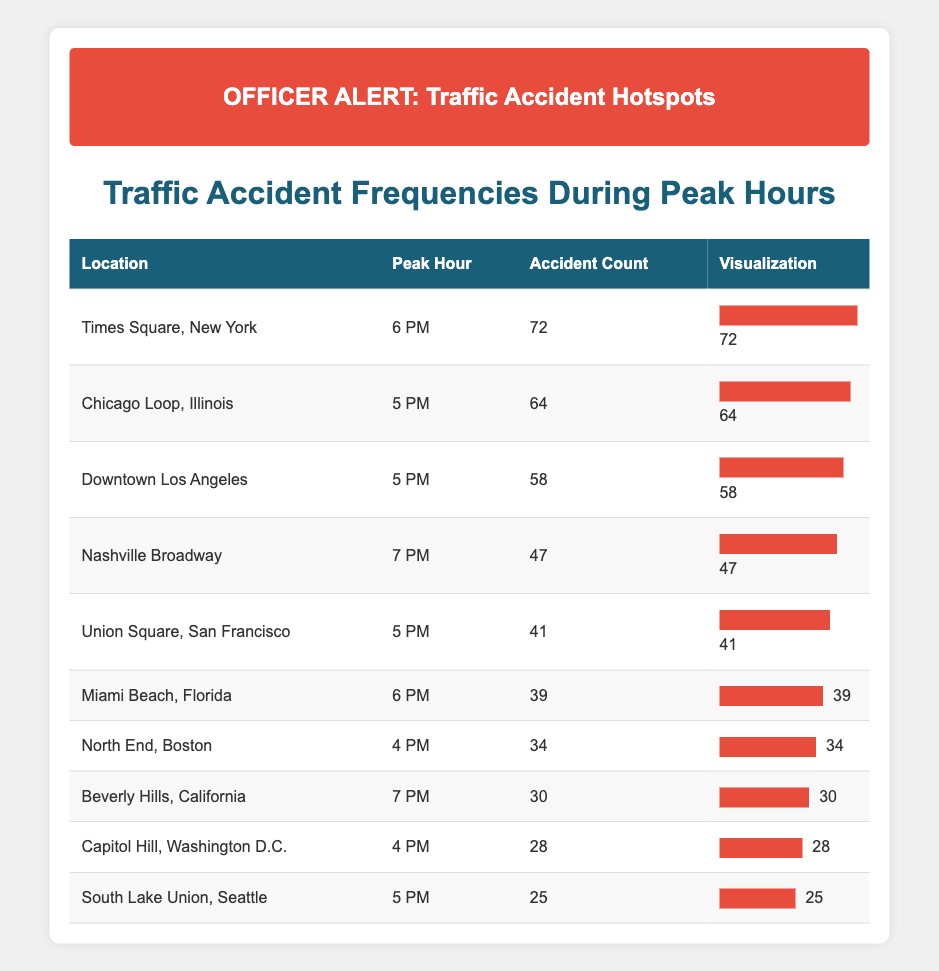What is the peak hour for Downtown Los Angeles? The table lists Downtown Los Angeles with a peak hour of 5 PM. This information is directly stated in the relevant row of the table.
Answer: 5 PM Which location has the highest accident count and what is that count? By reviewing the accident counts in the table, Times Square, New York has the highest accident count of 72, as indicated in its row.
Answer: 72 How many accidents occurred in total during the peak hours listed in the table? To find the total, sum all the accident counts: 58 + 72 + 34 + 41 + 25 + 47 + 64 + 39 + 28 + 30 + 25 =  439. Thus, the total number of accidents during peak hours is 439.
Answer: 439 Is the accident count in Chicago Loop, Illinois greater than that in Miami Beach, Florida? Chicago Loop has an accident count of 64 while Miami Beach has 39. Since 64 is greater than 39, the statement is true.
Answer: Yes What is the average accident count for locations with a peak hour of 5 PM? The locations with a peak hour of 5 PM are Downtown Los Angeles (58), Chicago Loop (64), Union Square (41), and South Lake Union (25). The sum is 58 + 64 + 41 + 25 = 188. The average is 188 divided by 4, which equals 47.
Answer: 47 How many locations listed have a peak hour of 6 PM? The table shows two locations, Times Square, New York and Miami Beach, Florida, both having a peak hour of 6 PM. Therefore, the answer is 2.
Answer: 2 Which city has a lower accident count, Capitol Hill, Washington D.C. or South Lake Union, Seattle? The accident count for Capitol Hill is 28, and for South Lake Union it is 25. Since 25 is less than 28, South Lake Union has the lower count.
Answer: South Lake Union, Seattle What is the difference between the accident counts of Times Square, New York and Nashville Broadway? The accident count for Times Square is 72, and for Nashville Broadway, it's 47. The difference is 72 - 47 = 25. Therefore, the difference is 25.
Answer: 25 How many locations have an accident count of less than 30? From the table, only Capitol Hill with 28 and South Lake Union with 25 have counts less than 30, which makes a total of 2 locations.
Answer: 2 